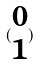<formula> <loc_0><loc_0><loc_500><loc_500>( \begin{matrix} 0 \\ 1 \end{matrix} )</formula> 